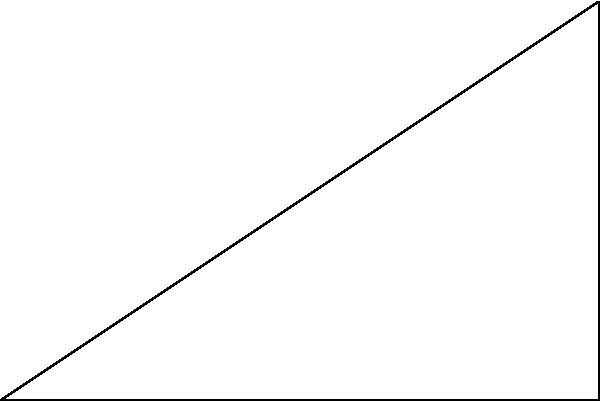As a freelance writer who values privacy and mental well-being, you've been tasked with creating a geometry problem for a client's educational content. In a right-angled triangle ABC, the hypotenuse AC measures 10 units, and the side BC is 4 units long. Calculate the length of the altitude (h) drawn from point A to the side BC. Let's approach this step-by-step:

1) In a right-angled triangle, we can use the Pythagorean theorem: $a^2 + b^2 = c^2$, where c is the hypotenuse.

2) We know the hypotenuse (AC) is 10 units and one side (BC) is 4 units. Let's call the unknown side (AB) x.

3) Applying the Pythagorean theorem:
   $x^2 + 4^2 = 10^2$

4) Simplify:
   $x^2 + 16 = 100$

5) Solve for x:
   $x^2 = 84$
   $x = \sqrt{84} = 2\sqrt{21} \approx 9.17$ units

6) Now we have a right-angled triangle with base 4 and hypotenuse 10.

7) To find the altitude (h), we can use the formula: $\text{Area} = \frac{1}{2} \times \text{base} \times \text{height}$

8) We can also calculate the area using Heron's formula:
   $\text{Area} = \sqrt{s(s-a)(s-b)(s-c)}$
   where $s = \frac{a+b+c}{2}$ (semi-perimeter)

9) Calculate s:
   $s = \frac{4 + 9.17 + 10}{2} = 11.585$

10) Apply Heron's formula:
    $\text{Area} = \sqrt{11.585(11.585-4)(11.585-9.17)(11.585-10)} \approx 18.33$

11) Now we can find h:
    $18.33 = \frac{1}{2} \times 4 \times h$
    $h = \frac{2 \times 18.33}{4} = 9.165$ units

Therefore, the altitude (h) is approximately 9.17 units.
Answer: $9.17$ units 